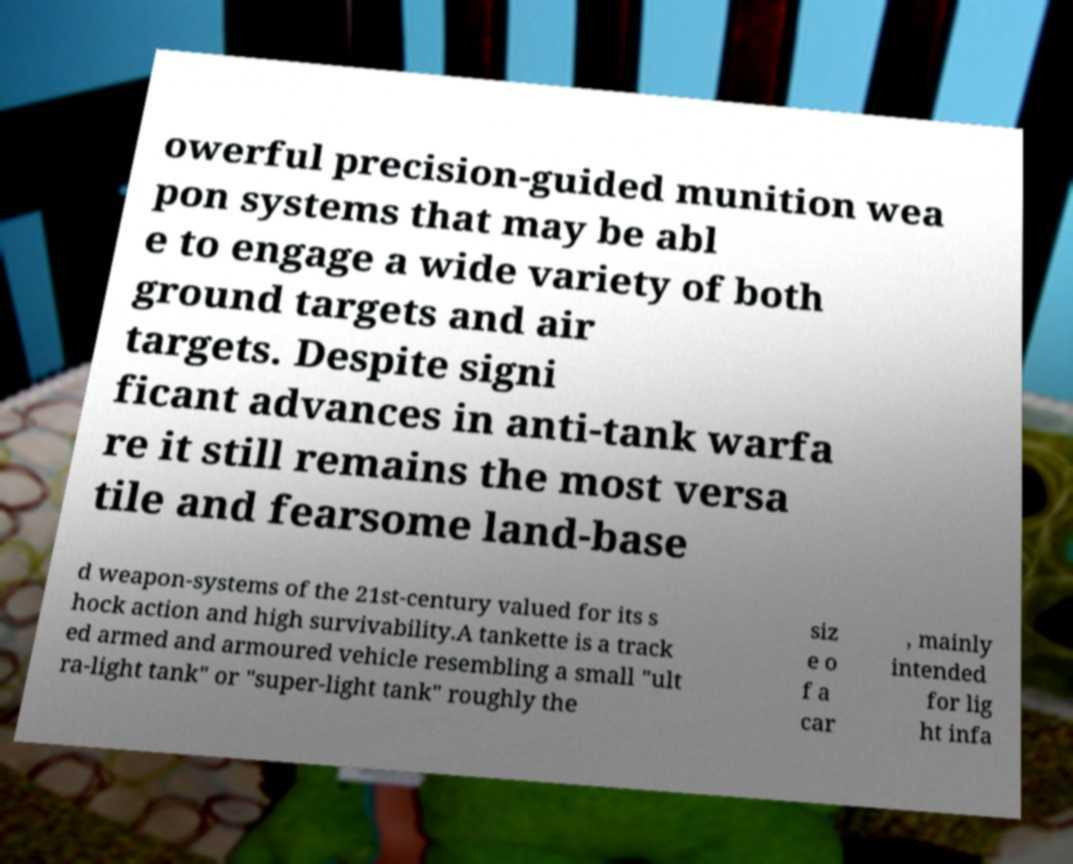Can you accurately transcribe the text from the provided image for me? owerful precision-guided munition wea pon systems that may be abl e to engage a wide variety of both ground targets and air targets. Despite signi ficant advances in anti-tank warfa re it still remains the most versa tile and fearsome land-base d weapon-systems of the 21st-century valued for its s hock action and high survivability.A tankette is a track ed armed and armoured vehicle resembling a small "ult ra-light tank" or "super-light tank" roughly the siz e o f a car , mainly intended for lig ht infa 